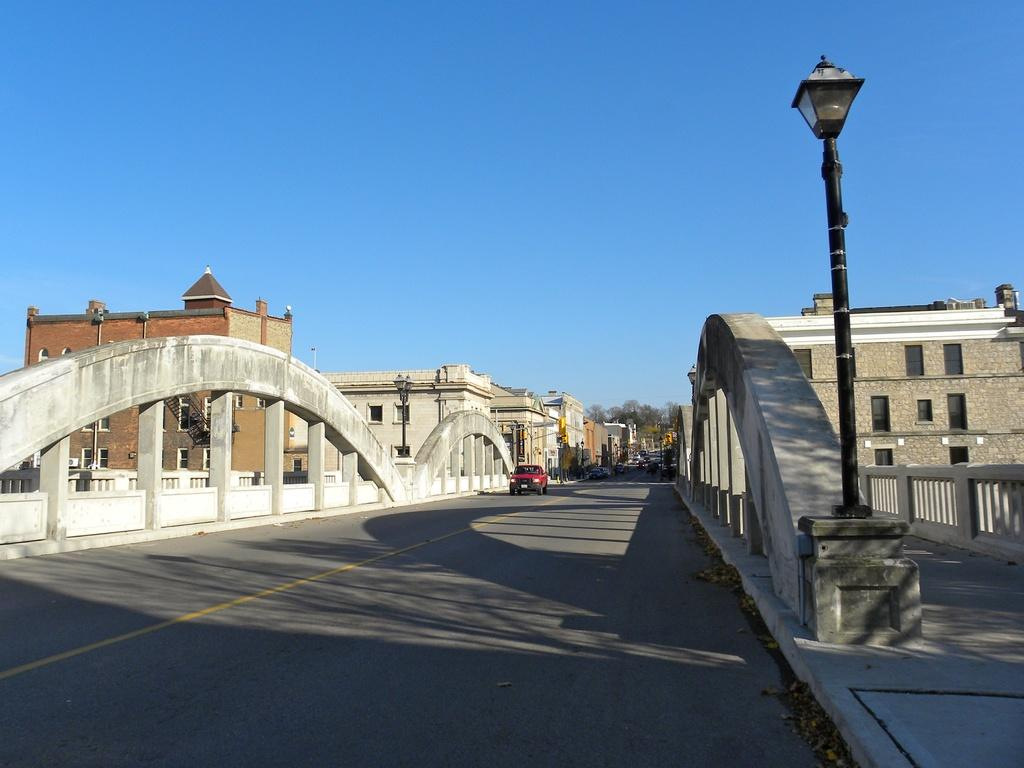What type of structures can be seen in the image? There are buildings in the image. What mode of transportation can be seen on the road in the image? Motor vehicles are present on the road in the image. Can you describe any architectural features in the image? Staircases and railings are visible in the image. What other objects can be seen in the image? Street poles and street lights are visible in the image. What type of vegetation is present in the image? Trees are present in the image. What part of the natural environment is visible in the image? The sky is visible in the image. Where is the market located in the image? There is no market present in the image. What type of industry can be seen in the image? There is no industry present in the image. 